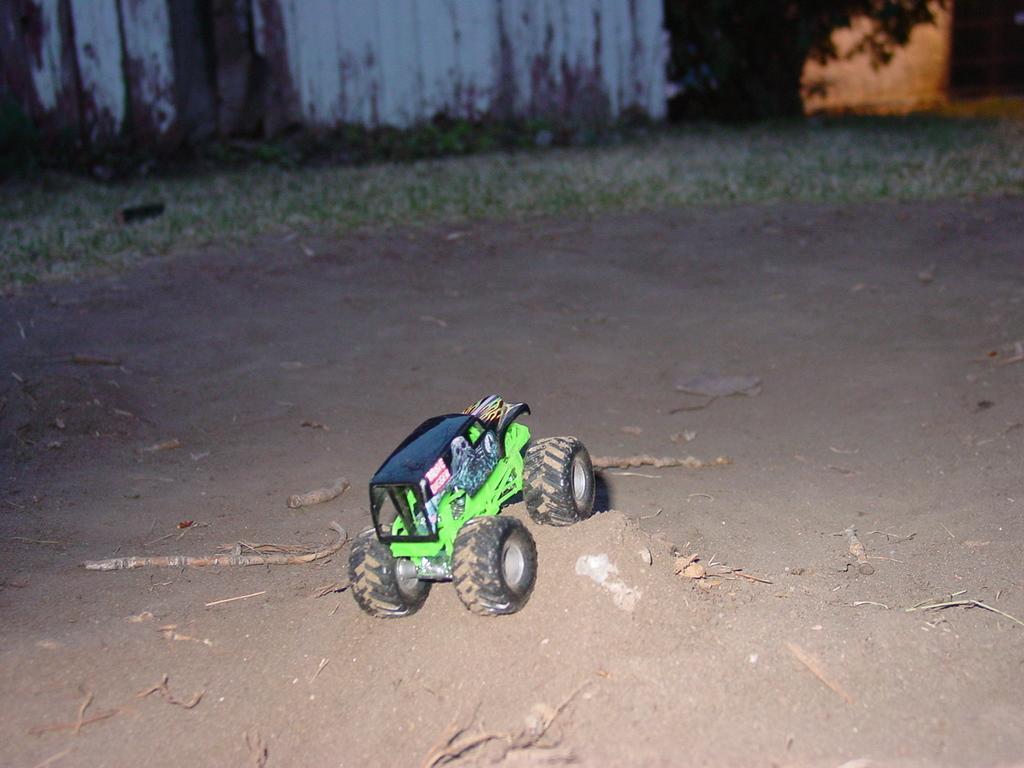How would you summarize this image in a sentence or two? In this picture there is a truck toy which is kept on the sand. In the background I can see the building's wall and grass. 